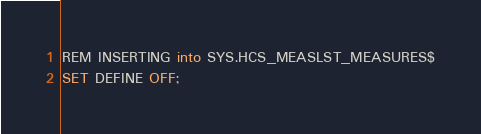Convert code to text. <code><loc_0><loc_0><loc_500><loc_500><_SQL_>REM INSERTING into SYS.HCS_MEASLST_MEASURES$
SET DEFINE OFF;
</code> 